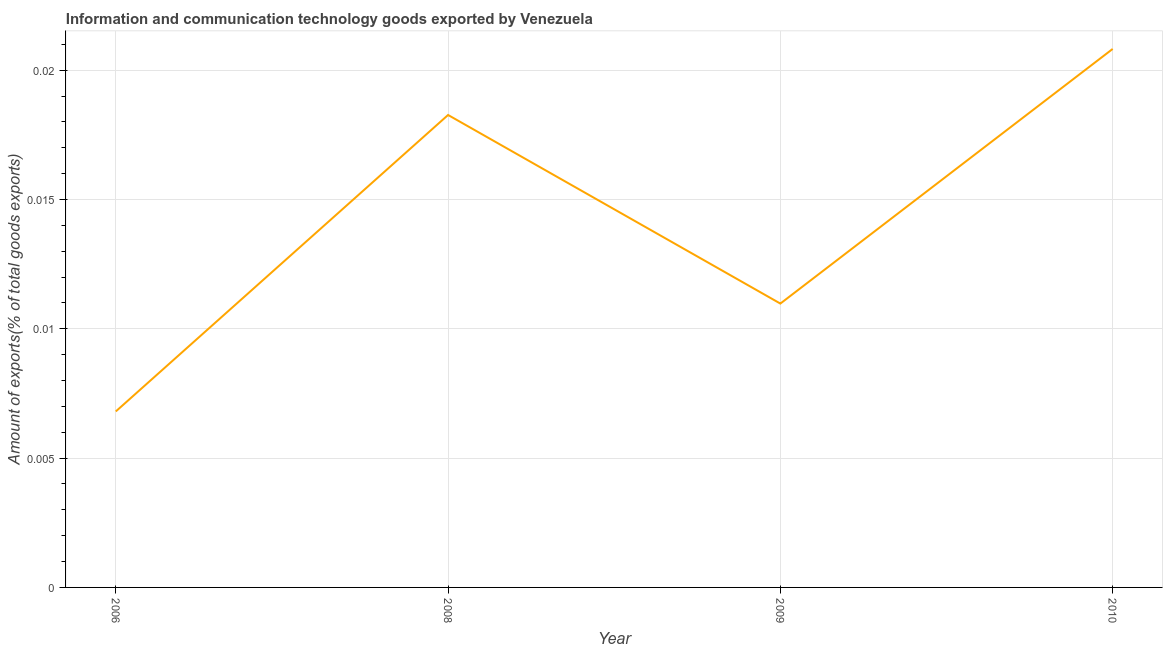What is the amount of ict goods exports in 2006?
Ensure brevity in your answer.  0.01. Across all years, what is the maximum amount of ict goods exports?
Offer a terse response. 0.02. Across all years, what is the minimum amount of ict goods exports?
Make the answer very short. 0.01. In which year was the amount of ict goods exports minimum?
Ensure brevity in your answer.  2006. What is the sum of the amount of ict goods exports?
Provide a succinct answer. 0.06. What is the difference between the amount of ict goods exports in 2006 and 2009?
Provide a succinct answer. -0. What is the average amount of ict goods exports per year?
Make the answer very short. 0.01. What is the median amount of ict goods exports?
Offer a very short reply. 0.01. In how many years, is the amount of ict goods exports greater than 0.017 %?
Provide a succinct answer. 2. What is the ratio of the amount of ict goods exports in 2006 to that in 2010?
Make the answer very short. 0.33. What is the difference between the highest and the second highest amount of ict goods exports?
Provide a succinct answer. 0. Is the sum of the amount of ict goods exports in 2008 and 2009 greater than the maximum amount of ict goods exports across all years?
Provide a short and direct response. Yes. What is the difference between the highest and the lowest amount of ict goods exports?
Give a very brief answer. 0.01. How many lines are there?
Your answer should be very brief. 1. How many years are there in the graph?
Your answer should be compact. 4. What is the difference between two consecutive major ticks on the Y-axis?
Offer a very short reply. 0.01. Does the graph contain any zero values?
Your answer should be compact. No. Does the graph contain grids?
Offer a very short reply. Yes. What is the title of the graph?
Ensure brevity in your answer.  Information and communication technology goods exported by Venezuela. What is the label or title of the X-axis?
Provide a succinct answer. Year. What is the label or title of the Y-axis?
Offer a terse response. Amount of exports(% of total goods exports). What is the Amount of exports(% of total goods exports) of 2006?
Ensure brevity in your answer.  0.01. What is the Amount of exports(% of total goods exports) of 2008?
Your answer should be compact. 0.02. What is the Amount of exports(% of total goods exports) in 2009?
Your answer should be compact. 0.01. What is the Amount of exports(% of total goods exports) of 2010?
Ensure brevity in your answer.  0.02. What is the difference between the Amount of exports(% of total goods exports) in 2006 and 2008?
Your answer should be compact. -0.01. What is the difference between the Amount of exports(% of total goods exports) in 2006 and 2009?
Provide a short and direct response. -0. What is the difference between the Amount of exports(% of total goods exports) in 2006 and 2010?
Provide a succinct answer. -0.01. What is the difference between the Amount of exports(% of total goods exports) in 2008 and 2009?
Offer a very short reply. 0.01. What is the difference between the Amount of exports(% of total goods exports) in 2008 and 2010?
Provide a succinct answer. -0. What is the difference between the Amount of exports(% of total goods exports) in 2009 and 2010?
Your answer should be compact. -0.01. What is the ratio of the Amount of exports(% of total goods exports) in 2006 to that in 2008?
Keep it short and to the point. 0.37. What is the ratio of the Amount of exports(% of total goods exports) in 2006 to that in 2009?
Offer a terse response. 0.62. What is the ratio of the Amount of exports(% of total goods exports) in 2006 to that in 2010?
Your answer should be compact. 0.33. What is the ratio of the Amount of exports(% of total goods exports) in 2008 to that in 2009?
Keep it short and to the point. 1.66. What is the ratio of the Amount of exports(% of total goods exports) in 2008 to that in 2010?
Your answer should be very brief. 0.88. What is the ratio of the Amount of exports(% of total goods exports) in 2009 to that in 2010?
Provide a succinct answer. 0.53. 